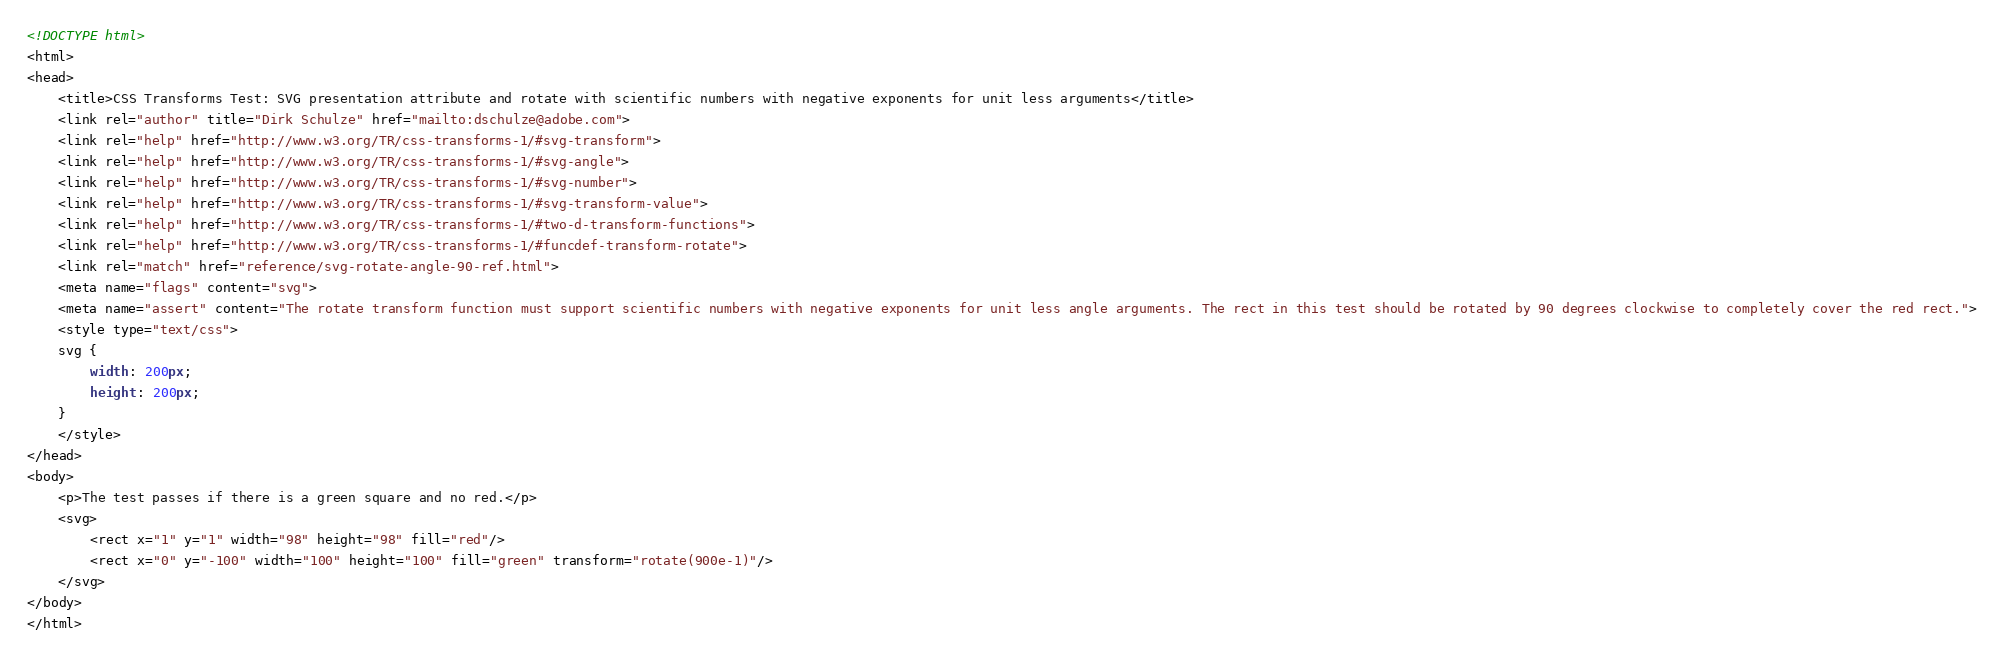<code> <loc_0><loc_0><loc_500><loc_500><_HTML_><!DOCTYPE html>
<html>
<head>
    <title>CSS Transforms Test: SVG presentation attribute and rotate with scientific numbers with negative exponents for unit less arguments</title>
    <link rel="author" title="Dirk Schulze" href="mailto:dschulze@adobe.com">
    <link rel="help" href="http://www.w3.org/TR/css-transforms-1/#svg-transform">
    <link rel="help" href="http://www.w3.org/TR/css-transforms-1/#svg-angle">
    <link rel="help" href="http://www.w3.org/TR/css-transforms-1/#svg-number">
    <link rel="help" href="http://www.w3.org/TR/css-transforms-1/#svg-transform-value">
    <link rel="help" href="http://www.w3.org/TR/css-transforms-1/#two-d-transform-functions">
    <link rel="help" href="http://www.w3.org/TR/css-transforms-1/#funcdef-transform-rotate">
    <link rel="match" href="reference/svg-rotate-angle-90-ref.html">
    <meta name="flags" content="svg">
    <meta name="assert" content="The rotate transform function must support scientific numbers with negative exponents for unit less angle arguments. The rect in this test should be rotated by 90 degrees clockwise to completely cover the red rect.">
    <style type="text/css">
    svg {
        width: 200px;
        height: 200px;
    }
    </style>
</head>
<body>
    <p>The test passes if there is a green square and no red.</p>
    <svg>
        <rect x="1" y="1" width="98" height="98" fill="red"/>
        <rect x="0" y="-100" width="100" height="100" fill="green" transform="rotate(900e-1)"/>
    </svg>
</body>
</html>
</code> 